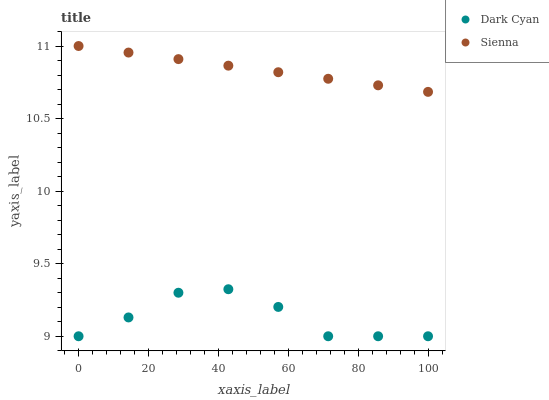Does Dark Cyan have the minimum area under the curve?
Answer yes or no. Yes. Does Sienna have the maximum area under the curve?
Answer yes or no. Yes. Does Sienna have the minimum area under the curve?
Answer yes or no. No. Is Sienna the smoothest?
Answer yes or no. Yes. Is Dark Cyan the roughest?
Answer yes or no. Yes. Is Sienna the roughest?
Answer yes or no. No. Does Dark Cyan have the lowest value?
Answer yes or no. Yes. Does Sienna have the lowest value?
Answer yes or no. No. Does Sienna have the highest value?
Answer yes or no. Yes. Is Dark Cyan less than Sienna?
Answer yes or no. Yes. Is Sienna greater than Dark Cyan?
Answer yes or no. Yes. Does Dark Cyan intersect Sienna?
Answer yes or no. No. 